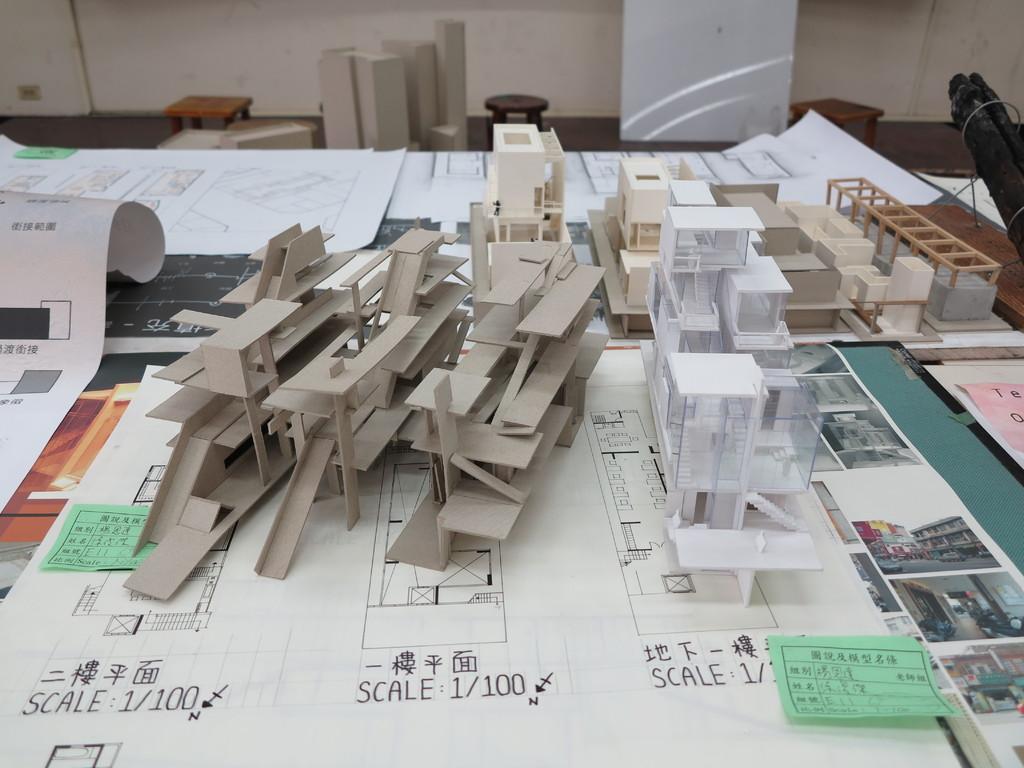What scale are the first two things to?
Provide a succinct answer. 1/100. 